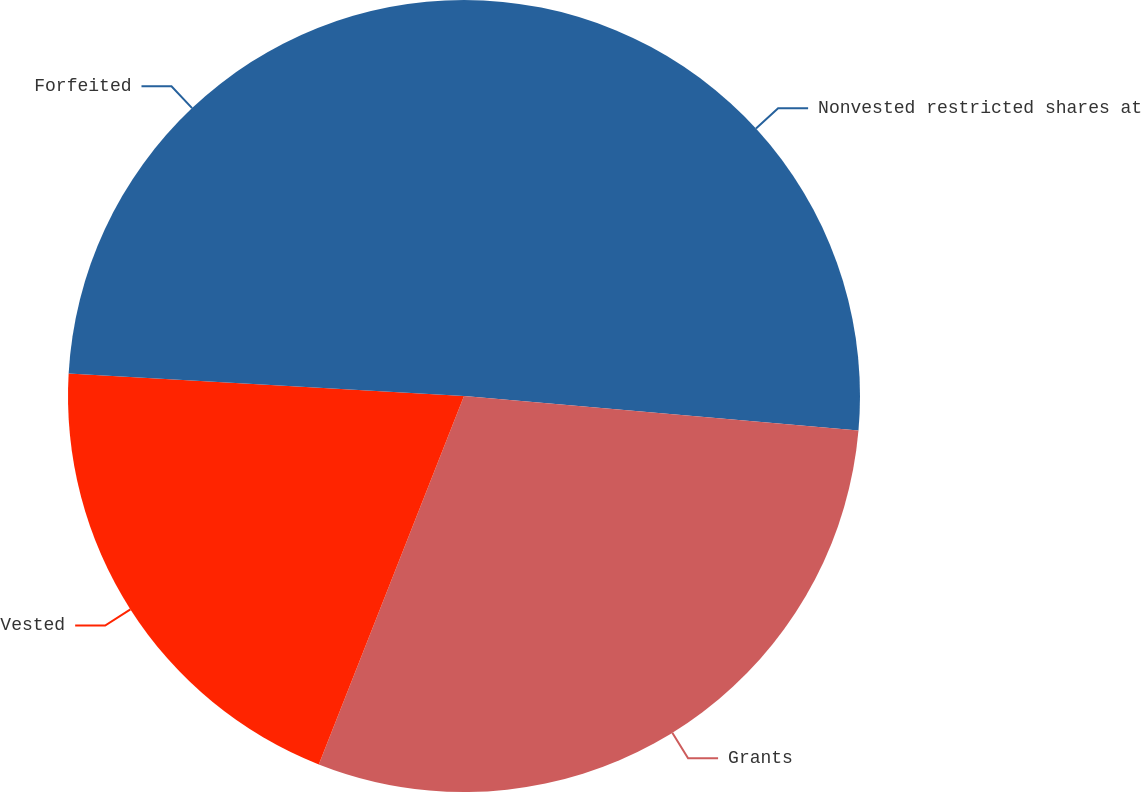Convert chart. <chart><loc_0><loc_0><loc_500><loc_500><pie_chart><fcel>Nonvested restricted shares at<fcel>Grants<fcel>Vested<fcel>Forfeited<nl><fcel>26.39%<fcel>29.58%<fcel>19.93%<fcel>24.09%<nl></chart> 